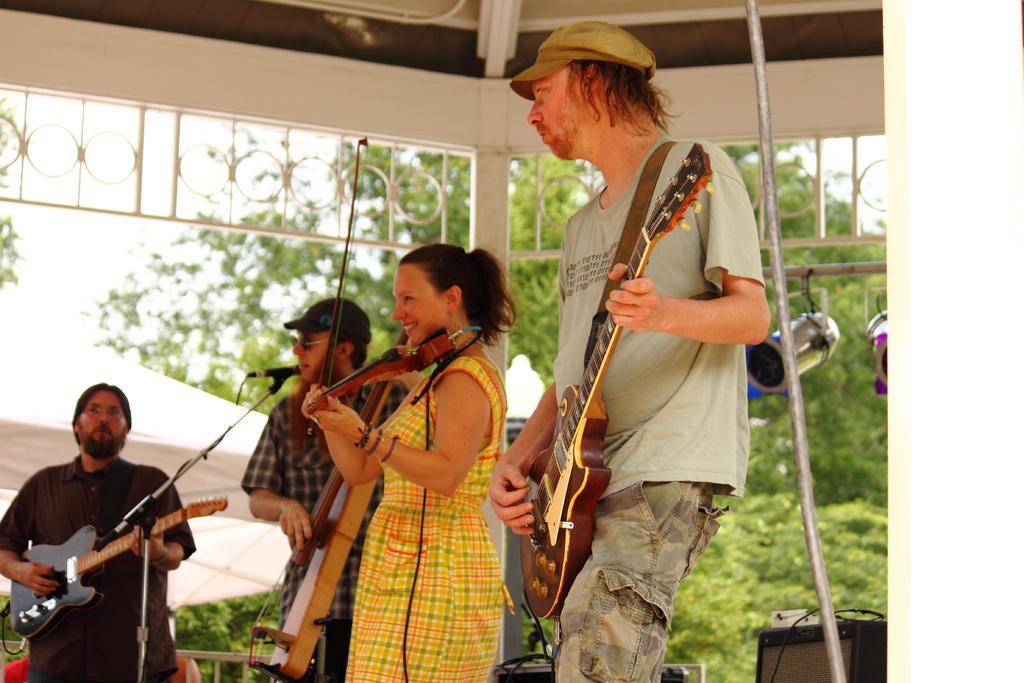Could you give a brief overview of what you see in this image? This picture is clicked under the tent. On the right corner there are focusing lights that are hanging. In the bottom right there is a speaker which may be placed on the ground. On the left corner there is a Man standing and playing Guitar and next to him there is another man standing, playing guitar and seems to be singing. In the center there is a Woman standing, smiling and playing Violin. On the right there is a Man standing and playing guitar. On the left there is a microphone which is attached to the stand. In the background we can see the trees and the sky. 